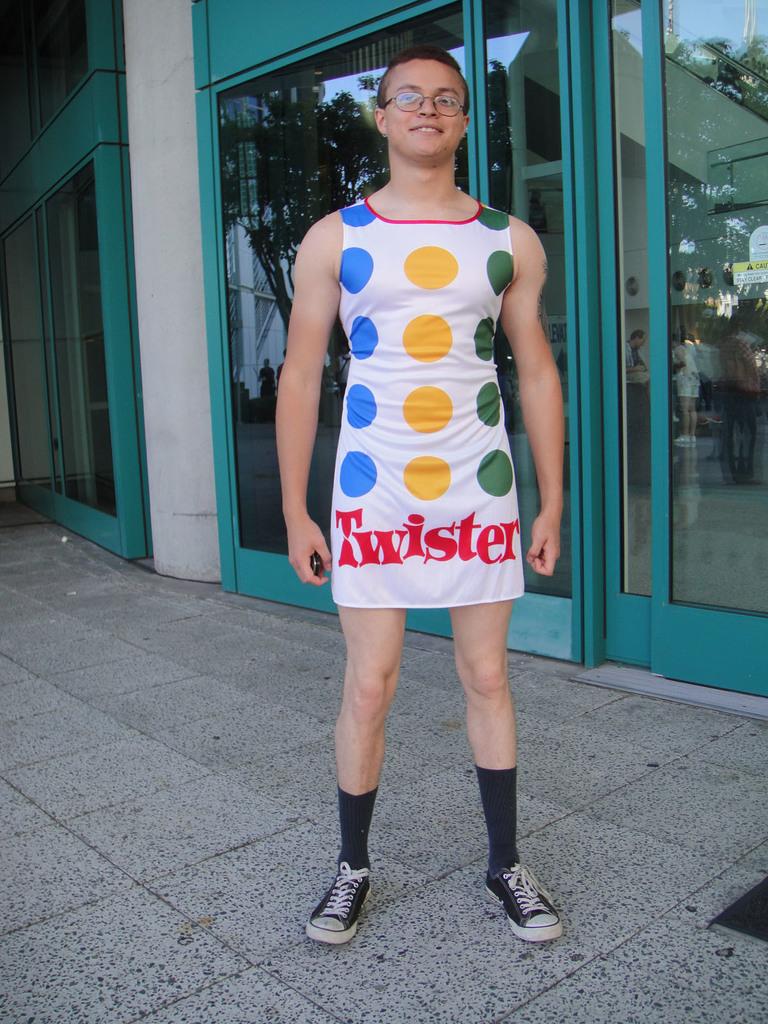What is the game listed on the man's dress?
Ensure brevity in your answer.  Twister. 